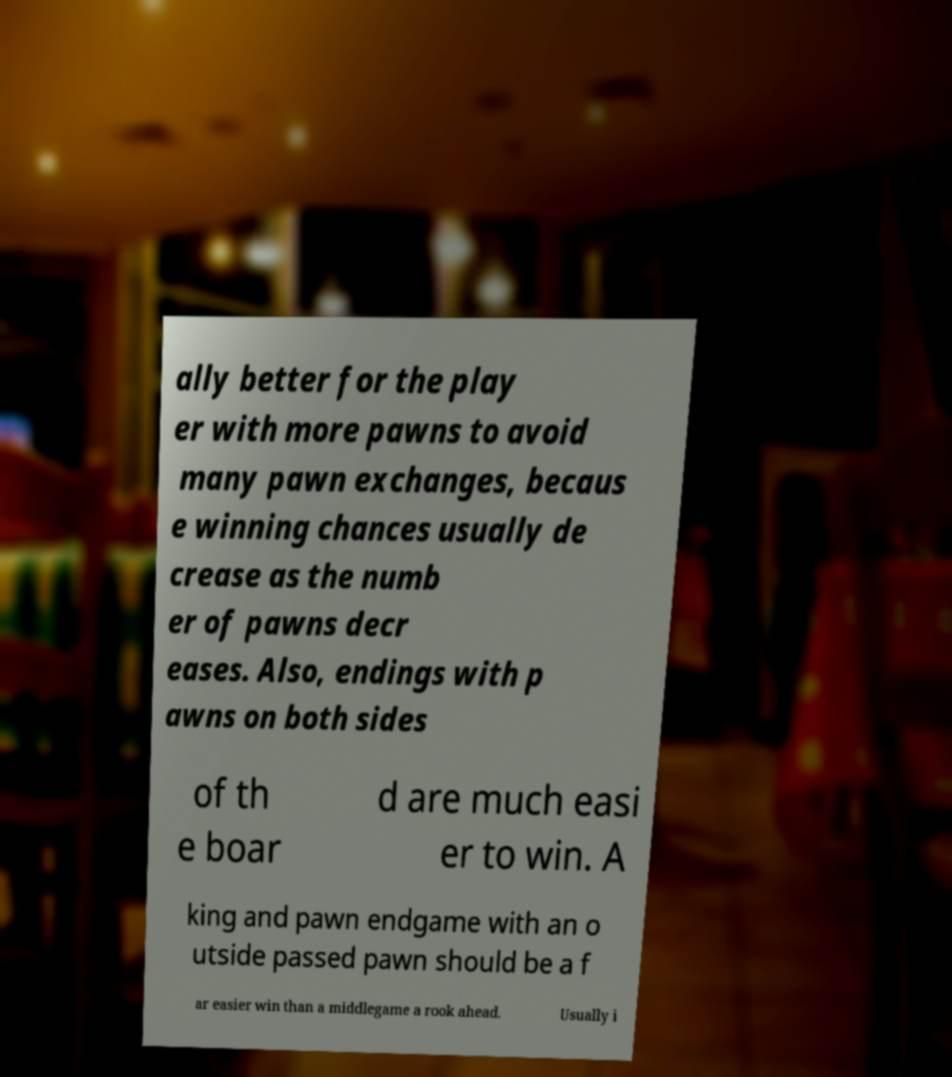Can you read and provide the text displayed in the image?This photo seems to have some interesting text. Can you extract and type it out for me? ally better for the play er with more pawns to avoid many pawn exchanges, becaus e winning chances usually de crease as the numb er of pawns decr eases. Also, endings with p awns on both sides of th e boar d are much easi er to win. A king and pawn endgame with an o utside passed pawn should be a f ar easier win than a middlegame a rook ahead. Usually i 